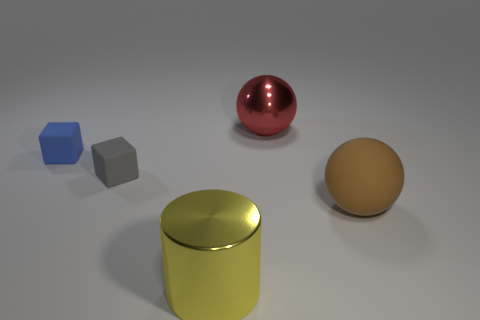How many cylinders are either large brown objects or large red things?
Give a very brief answer. 0. Is there a small thing in front of the shiny object behind the metallic object that is in front of the brown matte object?
Offer a very short reply. Yes. What color is the other rubber thing that is the same shape as the red thing?
Your response must be concise. Brown. What number of gray objects are large shiny cylinders or rubber things?
Offer a terse response. 1. What material is the big object to the left of the large thing behind the big brown ball?
Your response must be concise. Metal. Do the gray matte thing and the blue object have the same shape?
Provide a short and direct response. Yes. There is a sphere that is the same size as the red shiny thing; what color is it?
Provide a short and direct response. Brown. Are any rubber cylinders visible?
Offer a terse response. No. Are the cube that is in front of the blue rubber object and the blue object made of the same material?
Give a very brief answer. Yes. How many blue things have the same size as the gray matte object?
Your response must be concise. 1. 